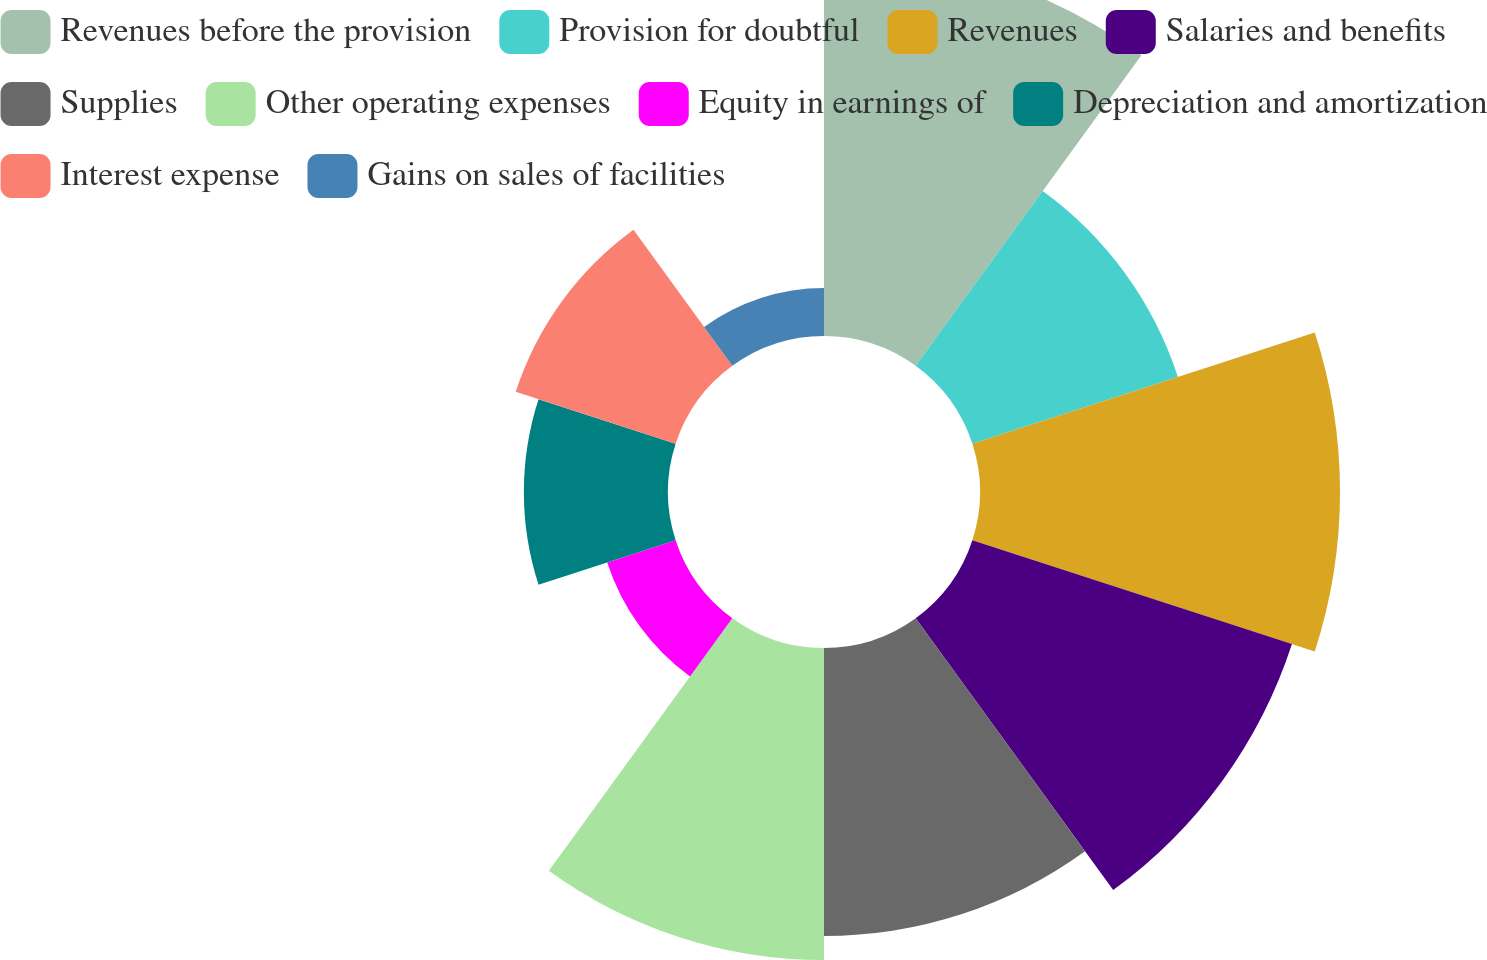Convert chart. <chart><loc_0><loc_0><loc_500><loc_500><pie_chart><fcel>Revenues before the provision<fcel>Provision for doubtful<fcel>Revenues<fcel>Salaries and benefits<fcel>Supplies<fcel>Other operating expenses<fcel>Equity in earnings of<fcel>Depreciation and amortization<fcel>Interest expense<fcel>Gains on sales of facilities<nl><fcel>16.49%<fcel>9.28%<fcel>15.46%<fcel>14.43%<fcel>12.37%<fcel>13.4%<fcel>3.09%<fcel>6.19%<fcel>7.22%<fcel>2.06%<nl></chart> 